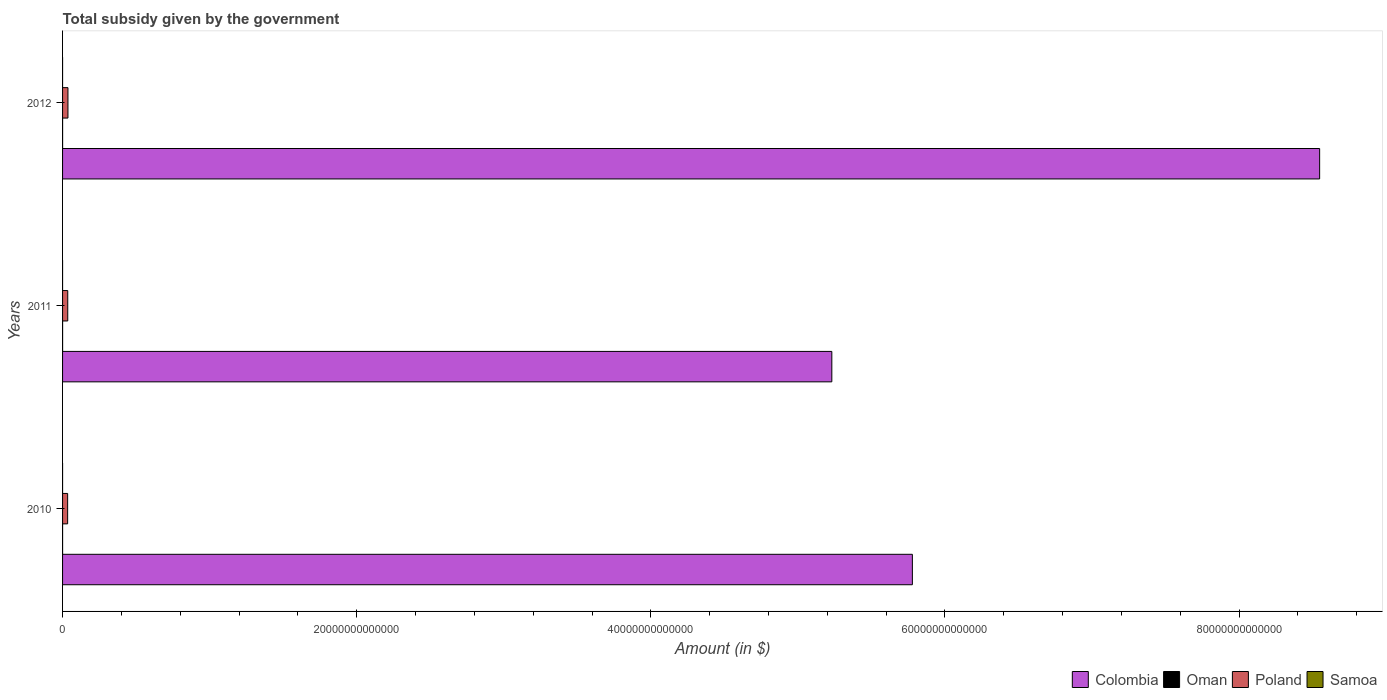How many groups of bars are there?
Ensure brevity in your answer.  3. Are the number of bars on each tick of the Y-axis equal?
Ensure brevity in your answer.  Yes. In how many cases, is the number of bars for a given year not equal to the number of legend labels?
Keep it short and to the point. 0. What is the total revenue collected by the government in Poland in 2011?
Provide a short and direct response. 3.53e+11. Across all years, what is the maximum total revenue collected by the government in Oman?
Provide a short and direct response. 1.88e+09. Across all years, what is the minimum total revenue collected by the government in Oman?
Offer a very short reply. 4.43e+08. What is the total total revenue collected by the government in Colombia in the graph?
Provide a short and direct response. 1.96e+14. What is the difference between the total revenue collected by the government in Poland in 2010 and that in 2012?
Make the answer very short. -2.18e+1. What is the difference between the total revenue collected by the government in Samoa in 2010 and the total revenue collected by the government in Colombia in 2011?
Keep it short and to the point. -5.23e+13. What is the average total revenue collected by the government in Colombia per year?
Give a very brief answer. 6.52e+13. In the year 2010, what is the difference between the total revenue collected by the government in Samoa and total revenue collected by the government in Poland?
Ensure brevity in your answer.  -3.45e+11. What is the ratio of the total revenue collected by the government in Colombia in 2010 to that in 2011?
Ensure brevity in your answer.  1.1. Is the difference between the total revenue collected by the government in Samoa in 2010 and 2012 greater than the difference between the total revenue collected by the government in Poland in 2010 and 2012?
Ensure brevity in your answer.  Yes. What is the difference between the highest and the second highest total revenue collected by the government in Oman?
Give a very brief answer. 2.43e+07. What is the difference between the highest and the lowest total revenue collected by the government in Poland?
Provide a short and direct response. 2.18e+1. Is it the case that in every year, the sum of the total revenue collected by the government in Oman and total revenue collected by the government in Samoa is greater than the sum of total revenue collected by the government in Colombia and total revenue collected by the government in Poland?
Offer a very short reply. No. What does the 4th bar from the bottom in 2012 represents?
Offer a terse response. Samoa. Is it the case that in every year, the sum of the total revenue collected by the government in Colombia and total revenue collected by the government in Samoa is greater than the total revenue collected by the government in Poland?
Your response must be concise. Yes. How many bars are there?
Provide a succinct answer. 12. What is the difference between two consecutive major ticks on the X-axis?
Provide a short and direct response. 2.00e+13. Does the graph contain grids?
Offer a very short reply. No. Where does the legend appear in the graph?
Offer a very short reply. Bottom right. How many legend labels are there?
Ensure brevity in your answer.  4. How are the legend labels stacked?
Provide a succinct answer. Horizontal. What is the title of the graph?
Keep it short and to the point. Total subsidy given by the government. Does "Antigua and Barbuda" appear as one of the legend labels in the graph?
Offer a terse response. No. What is the label or title of the X-axis?
Your answer should be compact. Amount (in $). What is the label or title of the Y-axis?
Your response must be concise. Years. What is the Amount (in $) of Colombia in 2010?
Your answer should be compact. 5.78e+13. What is the Amount (in $) in Oman in 2010?
Give a very brief answer. 4.43e+08. What is the Amount (in $) in Poland in 2010?
Provide a short and direct response. 3.45e+11. What is the Amount (in $) in Samoa in 2010?
Ensure brevity in your answer.  1.88e+05. What is the Amount (in $) of Colombia in 2011?
Keep it short and to the point. 5.23e+13. What is the Amount (in $) in Oman in 2011?
Offer a terse response. 1.88e+09. What is the Amount (in $) of Poland in 2011?
Offer a very short reply. 3.53e+11. What is the Amount (in $) of Samoa in 2011?
Keep it short and to the point. 1.84e+05. What is the Amount (in $) in Colombia in 2012?
Provide a short and direct response. 8.55e+13. What is the Amount (in $) of Oman in 2012?
Your answer should be compact. 1.86e+09. What is the Amount (in $) in Poland in 2012?
Give a very brief answer. 3.67e+11. What is the Amount (in $) in Samoa in 2012?
Your answer should be very brief. 1.76e+05. Across all years, what is the maximum Amount (in $) in Colombia?
Provide a succinct answer. 8.55e+13. Across all years, what is the maximum Amount (in $) in Oman?
Keep it short and to the point. 1.88e+09. Across all years, what is the maximum Amount (in $) in Poland?
Provide a short and direct response. 3.67e+11. Across all years, what is the maximum Amount (in $) of Samoa?
Ensure brevity in your answer.  1.88e+05. Across all years, what is the minimum Amount (in $) of Colombia?
Your response must be concise. 5.23e+13. Across all years, what is the minimum Amount (in $) of Oman?
Provide a succinct answer. 4.43e+08. Across all years, what is the minimum Amount (in $) of Poland?
Give a very brief answer. 3.45e+11. Across all years, what is the minimum Amount (in $) of Samoa?
Offer a terse response. 1.76e+05. What is the total Amount (in $) in Colombia in the graph?
Your response must be concise. 1.96e+14. What is the total Amount (in $) of Oman in the graph?
Provide a short and direct response. 4.18e+09. What is the total Amount (in $) of Poland in the graph?
Give a very brief answer. 1.06e+12. What is the total Amount (in $) of Samoa in the graph?
Provide a short and direct response. 5.48e+05. What is the difference between the Amount (in $) in Colombia in 2010 and that in 2011?
Make the answer very short. 5.48e+12. What is the difference between the Amount (in $) in Oman in 2010 and that in 2011?
Your response must be concise. -1.44e+09. What is the difference between the Amount (in $) in Poland in 2010 and that in 2011?
Offer a very short reply. -7.96e+09. What is the difference between the Amount (in $) of Samoa in 2010 and that in 2011?
Provide a succinct answer. 4748.99. What is the difference between the Amount (in $) of Colombia in 2010 and that in 2012?
Keep it short and to the point. -2.77e+13. What is the difference between the Amount (in $) of Oman in 2010 and that in 2012?
Ensure brevity in your answer.  -1.41e+09. What is the difference between the Amount (in $) in Poland in 2010 and that in 2012?
Keep it short and to the point. -2.18e+1. What is the difference between the Amount (in $) of Samoa in 2010 and that in 2012?
Give a very brief answer. 1.25e+04. What is the difference between the Amount (in $) in Colombia in 2011 and that in 2012?
Offer a very short reply. -3.32e+13. What is the difference between the Amount (in $) of Oman in 2011 and that in 2012?
Your response must be concise. 2.43e+07. What is the difference between the Amount (in $) of Poland in 2011 and that in 2012?
Provide a short and direct response. -1.39e+1. What is the difference between the Amount (in $) in Samoa in 2011 and that in 2012?
Provide a short and direct response. 7706.28. What is the difference between the Amount (in $) in Colombia in 2010 and the Amount (in $) in Oman in 2011?
Your response must be concise. 5.78e+13. What is the difference between the Amount (in $) in Colombia in 2010 and the Amount (in $) in Poland in 2011?
Your answer should be very brief. 5.74e+13. What is the difference between the Amount (in $) of Colombia in 2010 and the Amount (in $) of Samoa in 2011?
Make the answer very short. 5.78e+13. What is the difference between the Amount (in $) of Oman in 2010 and the Amount (in $) of Poland in 2011?
Provide a succinct answer. -3.52e+11. What is the difference between the Amount (in $) of Oman in 2010 and the Amount (in $) of Samoa in 2011?
Provide a succinct answer. 4.43e+08. What is the difference between the Amount (in $) of Poland in 2010 and the Amount (in $) of Samoa in 2011?
Your answer should be very brief. 3.45e+11. What is the difference between the Amount (in $) of Colombia in 2010 and the Amount (in $) of Oman in 2012?
Your response must be concise. 5.78e+13. What is the difference between the Amount (in $) of Colombia in 2010 and the Amount (in $) of Poland in 2012?
Provide a succinct answer. 5.74e+13. What is the difference between the Amount (in $) of Colombia in 2010 and the Amount (in $) of Samoa in 2012?
Give a very brief answer. 5.78e+13. What is the difference between the Amount (in $) in Oman in 2010 and the Amount (in $) in Poland in 2012?
Provide a succinct answer. -3.66e+11. What is the difference between the Amount (in $) of Oman in 2010 and the Amount (in $) of Samoa in 2012?
Provide a succinct answer. 4.43e+08. What is the difference between the Amount (in $) of Poland in 2010 and the Amount (in $) of Samoa in 2012?
Provide a short and direct response. 3.45e+11. What is the difference between the Amount (in $) in Colombia in 2011 and the Amount (in $) in Oman in 2012?
Provide a succinct answer. 5.23e+13. What is the difference between the Amount (in $) in Colombia in 2011 and the Amount (in $) in Poland in 2012?
Ensure brevity in your answer.  5.19e+13. What is the difference between the Amount (in $) in Colombia in 2011 and the Amount (in $) in Samoa in 2012?
Offer a very short reply. 5.23e+13. What is the difference between the Amount (in $) in Oman in 2011 and the Amount (in $) in Poland in 2012?
Your response must be concise. -3.65e+11. What is the difference between the Amount (in $) in Oman in 2011 and the Amount (in $) in Samoa in 2012?
Provide a succinct answer. 1.88e+09. What is the difference between the Amount (in $) of Poland in 2011 and the Amount (in $) of Samoa in 2012?
Offer a very short reply. 3.53e+11. What is the average Amount (in $) in Colombia per year?
Provide a short and direct response. 6.52e+13. What is the average Amount (in $) of Oman per year?
Keep it short and to the point. 1.39e+09. What is the average Amount (in $) in Poland per year?
Your answer should be compact. 3.55e+11. What is the average Amount (in $) in Samoa per year?
Provide a short and direct response. 1.83e+05. In the year 2010, what is the difference between the Amount (in $) of Colombia and Amount (in $) of Oman?
Keep it short and to the point. 5.78e+13. In the year 2010, what is the difference between the Amount (in $) in Colombia and Amount (in $) in Poland?
Your response must be concise. 5.74e+13. In the year 2010, what is the difference between the Amount (in $) in Colombia and Amount (in $) in Samoa?
Your response must be concise. 5.78e+13. In the year 2010, what is the difference between the Amount (in $) of Oman and Amount (in $) of Poland?
Make the answer very short. -3.45e+11. In the year 2010, what is the difference between the Amount (in $) in Oman and Amount (in $) in Samoa?
Your response must be concise. 4.43e+08. In the year 2010, what is the difference between the Amount (in $) in Poland and Amount (in $) in Samoa?
Ensure brevity in your answer.  3.45e+11. In the year 2011, what is the difference between the Amount (in $) in Colombia and Amount (in $) in Oman?
Provide a succinct answer. 5.23e+13. In the year 2011, what is the difference between the Amount (in $) in Colombia and Amount (in $) in Poland?
Keep it short and to the point. 5.20e+13. In the year 2011, what is the difference between the Amount (in $) of Colombia and Amount (in $) of Samoa?
Provide a short and direct response. 5.23e+13. In the year 2011, what is the difference between the Amount (in $) of Oman and Amount (in $) of Poland?
Make the answer very short. -3.51e+11. In the year 2011, what is the difference between the Amount (in $) of Oman and Amount (in $) of Samoa?
Your answer should be very brief. 1.88e+09. In the year 2011, what is the difference between the Amount (in $) of Poland and Amount (in $) of Samoa?
Give a very brief answer. 3.53e+11. In the year 2012, what is the difference between the Amount (in $) in Colombia and Amount (in $) in Oman?
Provide a short and direct response. 8.55e+13. In the year 2012, what is the difference between the Amount (in $) of Colombia and Amount (in $) of Poland?
Make the answer very short. 8.51e+13. In the year 2012, what is the difference between the Amount (in $) of Colombia and Amount (in $) of Samoa?
Your answer should be compact. 8.55e+13. In the year 2012, what is the difference between the Amount (in $) of Oman and Amount (in $) of Poland?
Offer a terse response. -3.65e+11. In the year 2012, what is the difference between the Amount (in $) of Oman and Amount (in $) of Samoa?
Offer a terse response. 1.86e+09. In the year 2012, what is the difference between the Amount (in $) in Poland and Amount (in $) in Samoa?
Provide a succinct answer. 3.67e+11. What is the ratio of the Amount (in $) in Colombia in 2010 to that in 2011?
Keep it short and to the point. 1.1. What is the ratio of the Amount (in $) in Oman in 2010 to that in 2011?
Make the answer very short. 0.24. What is the ratio of the Amount (in $) of Poland in 2010 to that in 2011?
Offer a very short reply. 0.98. What is the ratio of the Amount (in $) of Samoa in 2010 to that in 2011?
Give a very brief answer. 1.03. What is the ratio of the Amount (in $) in Colombia in 2010 to that in 2012?
Offer a terse response. 0.68. What is the ratio of the Amount (in $) in Oman in 2010 to that in 2012?
Your answer should be very brief. 0.24. What is the ratio of the Amount (in $) of Poland in 2010 to that in 2012?
Give a very brief answer. 0.94. What is the ratio of the Amount (in $) in Samoa in 2010 to that in 2012?
Offer a very short reply. 1.07. What is the ratio of the Amount (in $) of Colombia in 2011 to that in 2012?
Your answer should be compact. 0.61. What is the ratio of the Amount (in $) in Oman in 2011 to that in 2012?
Give a very brief answer. 1.01. What is the ratio of the Amount (in $) of Poland in 2011 to that in 2012?
Offer a very short reply. 0.96. What is the ratio of the Amount (in $) in Samoa in 2011 to that in 2012?
Keep it short and to the point. 1.04. What is the difference between the highest and the second highest Amount (in $) of Colombia?
Offer a very short reply. 2.77e+13. What is the difference between the highest and the second highest Amount (in $) in Oman?
Your response must be concise. 2.43e+07. What is the difference between the highest and the second highest Amount (in $) of Poland?
Offer a very short reply. 1.39e+1. What is the difference between the highest and the second highest Amount (in $) in Samoa?
Ensure brevity in your answer.  4748.99. What is the difference between the highest and the lowest Amount (in $) of Colombia?
Keep it short and to the point. 3.32e+13. What is the difference between the highest and the lowest Amount (in $) of Oman?
Your answer should be very brief. 1.44e+09. What is the difference between the highest and the lowest Amount (in $) in Poland?
Your response must be concise. 2.18e+1. What is the difference between the highest and the lowest Amount (in $) of Samoa?
Provide a succinct answer. 1.25e+04. 